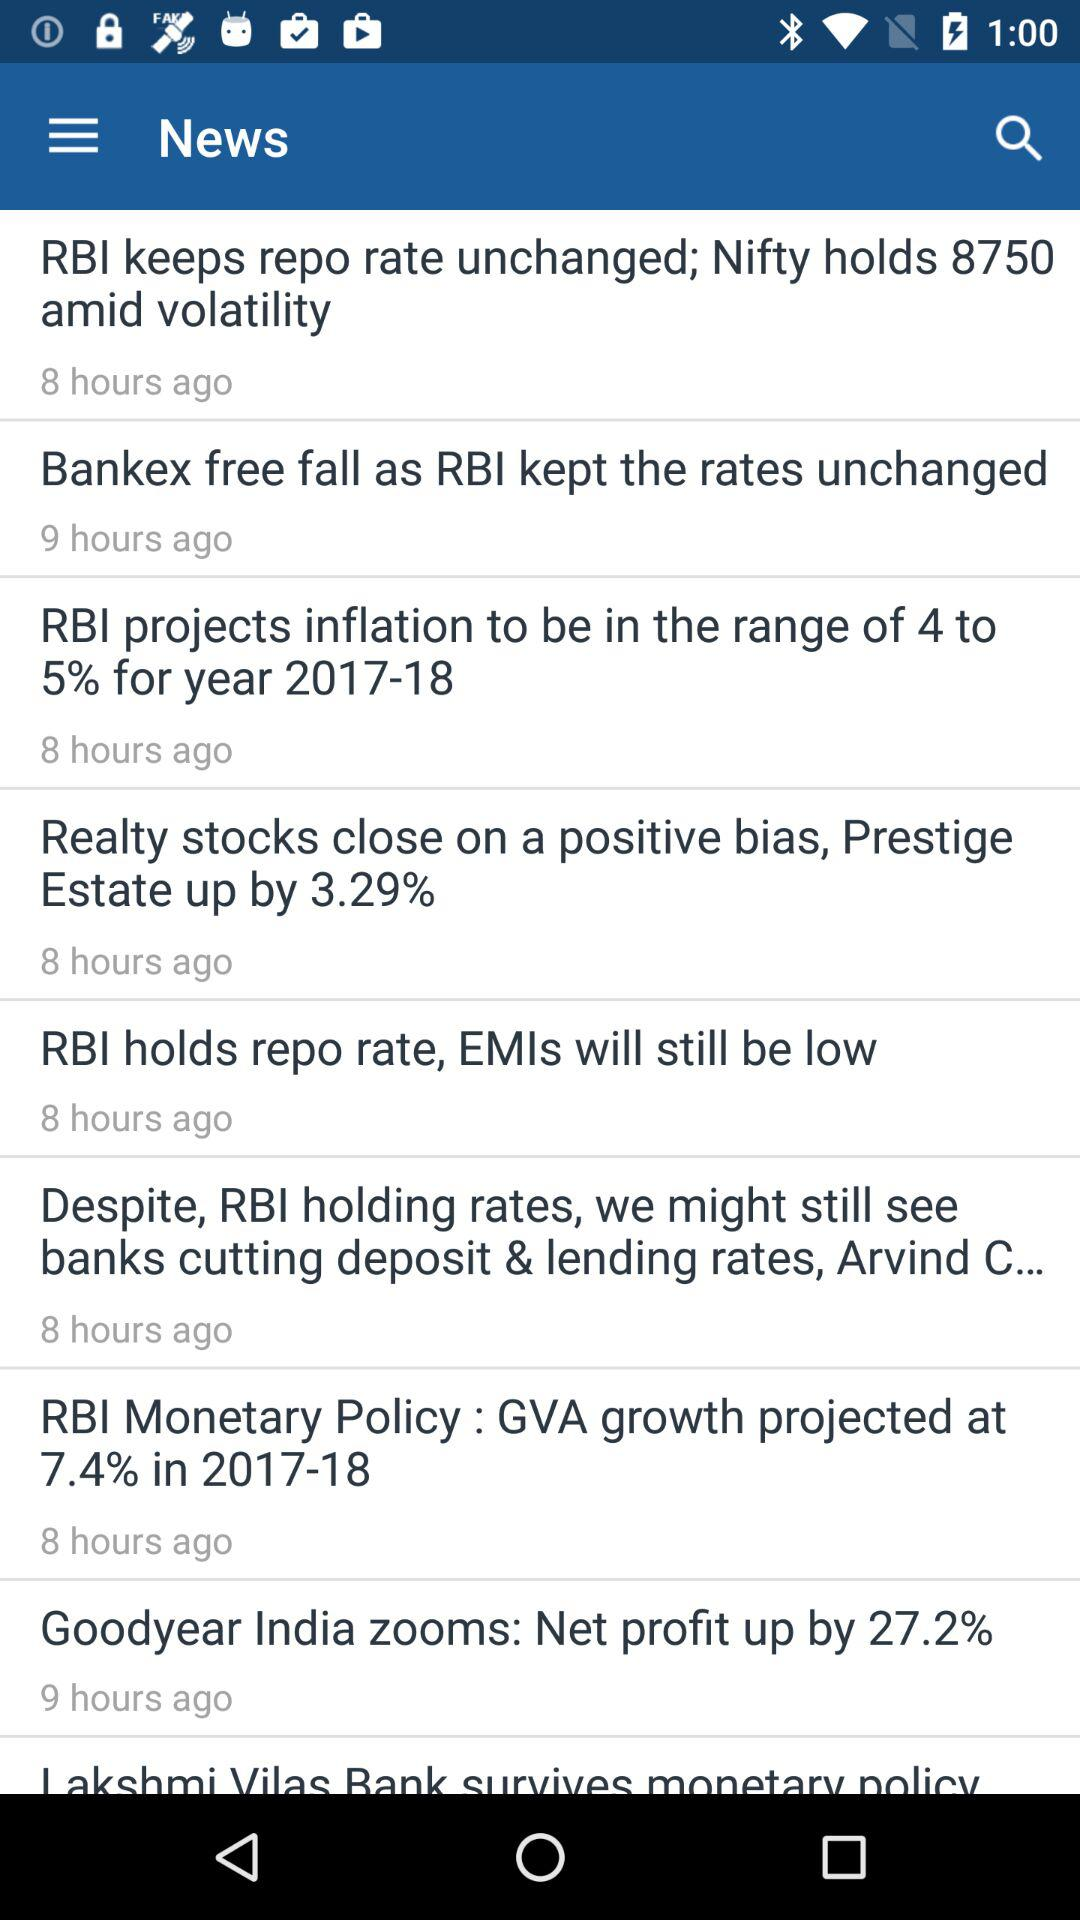How many hours ago was the most recent news item published?
Answer the question using a single word or phrase. 8 hours ago 